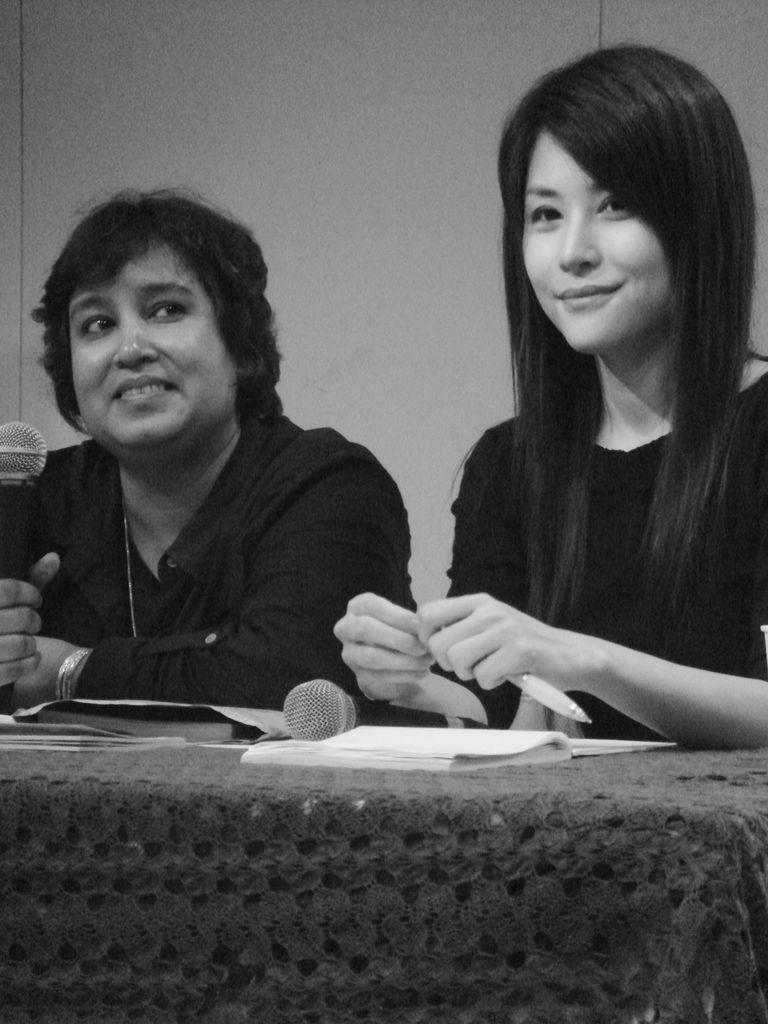How many women are in the image? There are two women in the image. What are the women doing in the image? The women are sitting on chairs and holding microphones. What is on the table in the image? There is a book and a cloth on the table. What type of quartz can be seen on the table in the image? There is no quartz present on the table in the image. Can you see a skateboard being used by the women in the image? There is no skateboard or any indication of skating in the image. 